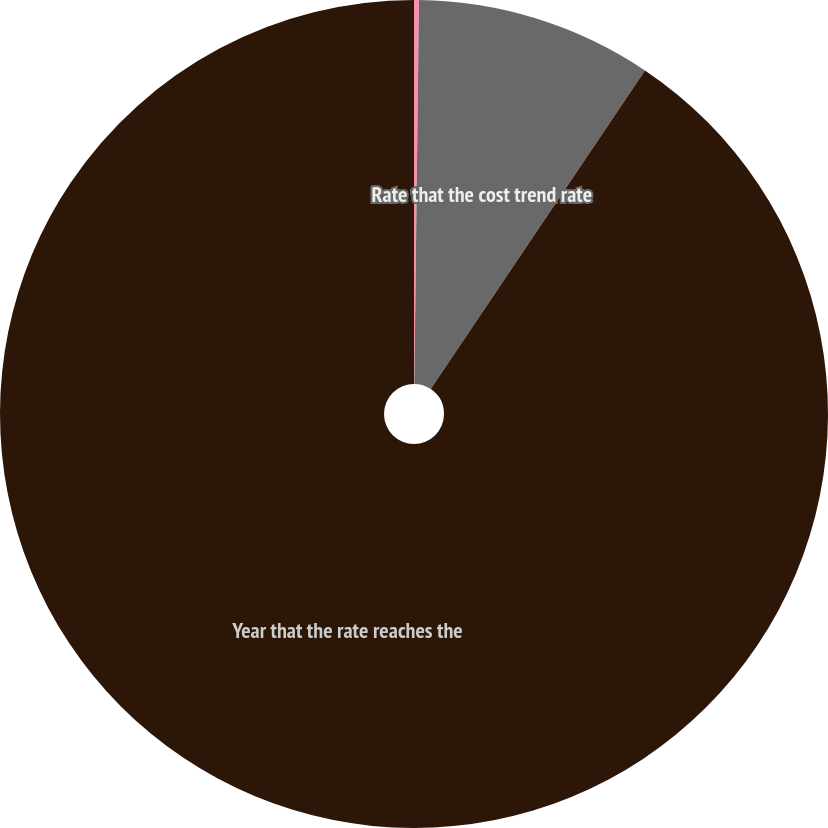Convert chart. <chart><loc_0><loc_0><loc_500><loc_500><pie_chart><fcel>Discount rate<fcel>Rate that the cost trend rate<fcel>Year that the rate reaches the<nl><fcel>0.19%<fcel>9.23%<fcel>90.58%<nl></chart> 